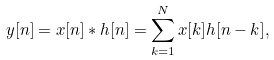Convert formula to latex. <formula><loc_0><loc_0><loc_500><loc_500>y [ n ] = x [ n ] * h [ n ] = \sum _ { k = 1 } ^ { N } x [ k ] h [ n - k ] ,</formula> 